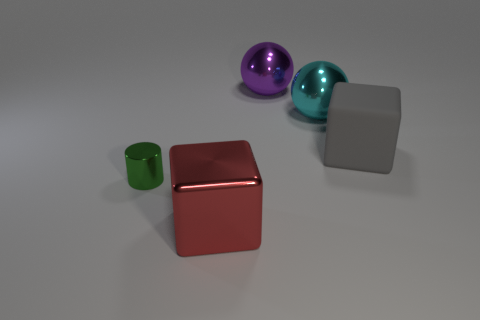Subtract all purple blocks. Subtract all green balls. How many blocks are left? 2 Add 4 cubes. How many objects exist? 9 Subtract all cylinders. How many objects are left? 4 Add 3 big purple metal balls. How many big purple metal balls exist? 4 Subtract 0 blue balls. How many objects are left? 5 Subtract all gray blocks. Subtract all big cyan objects. How many objects are left? 3 Add 5 metal balls. How many metal balls are left? 7 